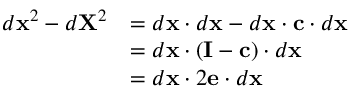<formula> <loc_0><loc_0><loc_500><loc_500>{ \begin{array} { r l } { d x ^ { 2 } - d X ^ { 2 } } & { = d x \cdot d x - d x \cdot c \cdot d x } \\ & { = d x \cdot ( I - c ) \cdot d x } \\ & { = d x \cdot 2 e \cdot d x } \end{array} }</formula> 